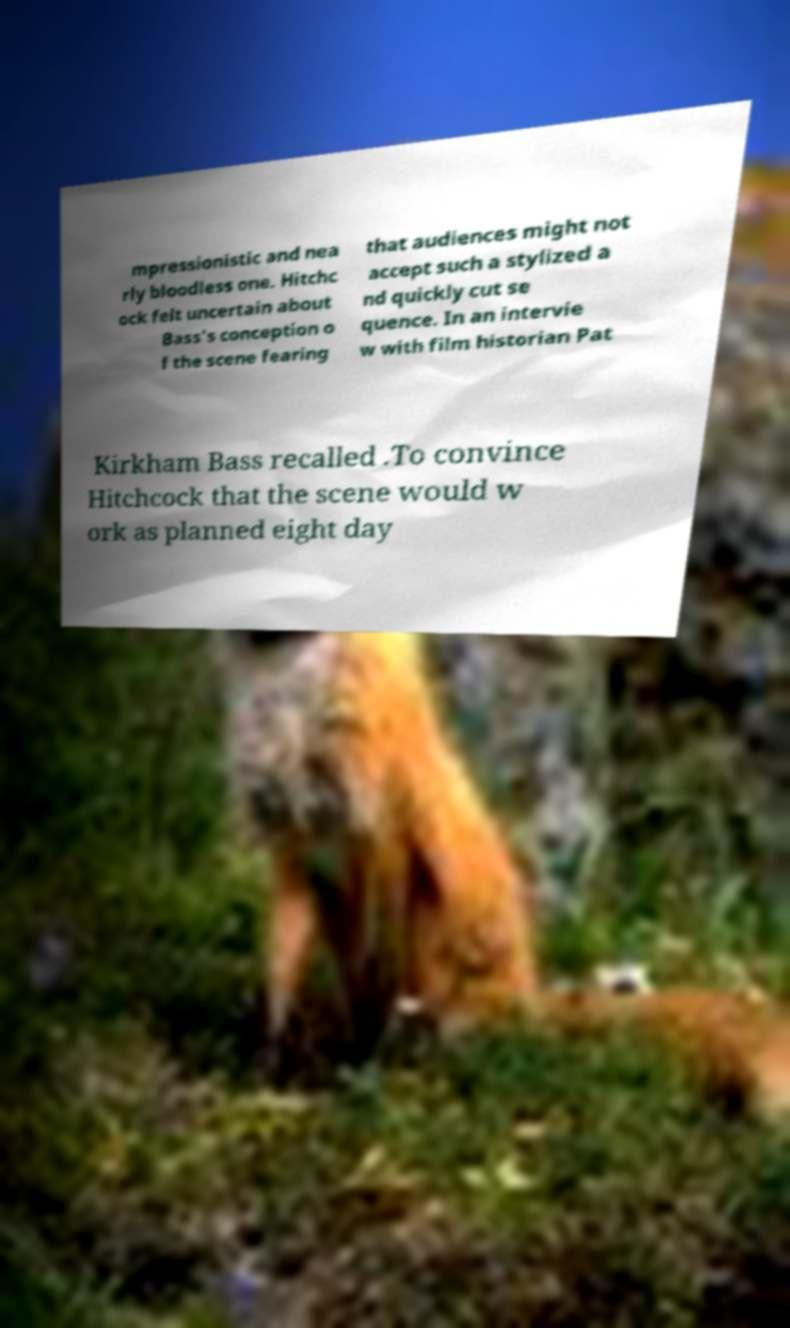Could you extract and type out the text from this image? mpressionistic and nea rly bloodless one. Hitchc ock felt uncertain about Bass's conception o f the scene fearing that audiences might not accept such a stylized a nd quickly cut se quence. In an intervie w with film historian Pat Kirkham Bass recalled .To convince Hitchcock that the scene would w ork as planned eight day 